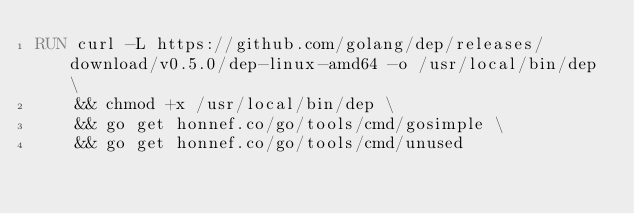Convert code to text. <code><loc_0><loc_0><loc_500><loc_500><_Dockerfile_>RUN curl -L https://github.com/golang/dep/releases/download/v0.5.0/dep-linux-amd64 -o /usr/local/bin/dep \
    && chmod +x /usr/local/bin/dep \
    && go get honnef.co/go/tools/cmd/gosimple \
    && go get honnef.co/go/tools/cmd/unused
</code> 